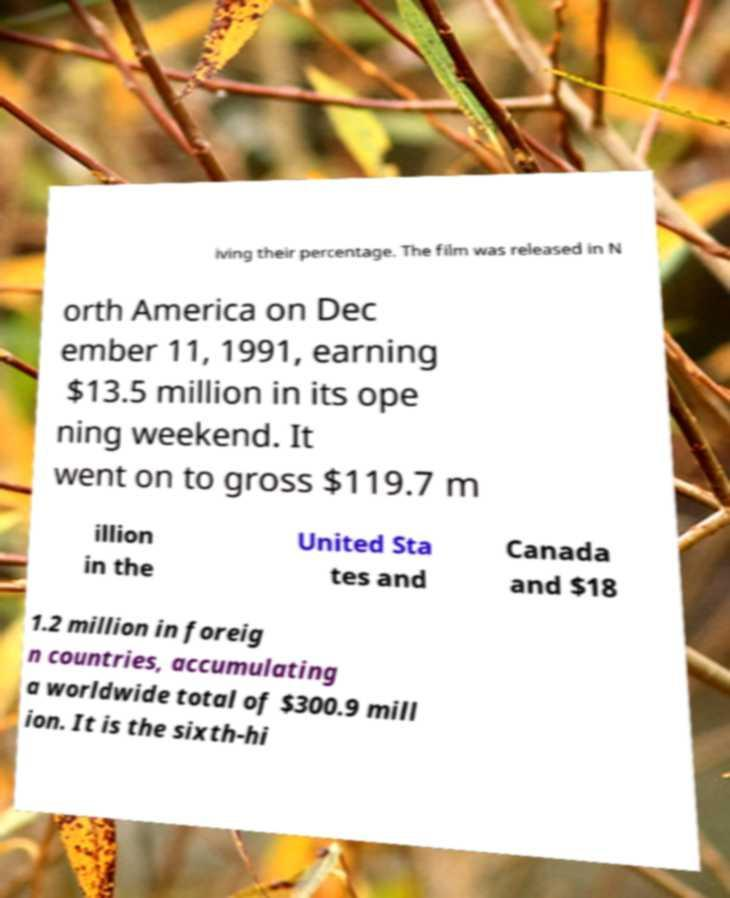Please read and relay the text visible in this image. What does it say? iving their percentage. The film was released in N orth America on Dec ember 11, 1991, earning $13.5 million in its ope ning weekend. It went on to gross $119.7 m illion in the United Sta tes and Canada and $18 1.2 million in foreig n countries, accumulating a worldwide total of $300.9 mill ion. It is the sixth-hi 